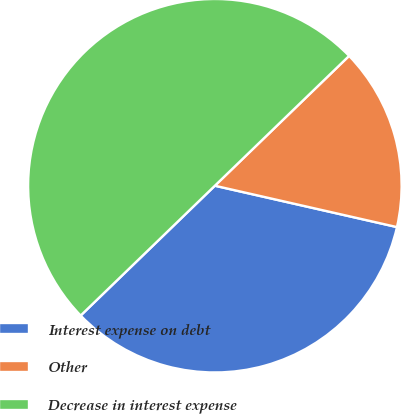<chart> <loc_0><loc_0><loc_500><loc_500><pie_chart><fcel>Interest expense on debt<fcel>Other<fcel>Decrease in interest expense<nl><fcel>34.21%<fcel>15.79%<fcel>50.0%<nl></chart> 